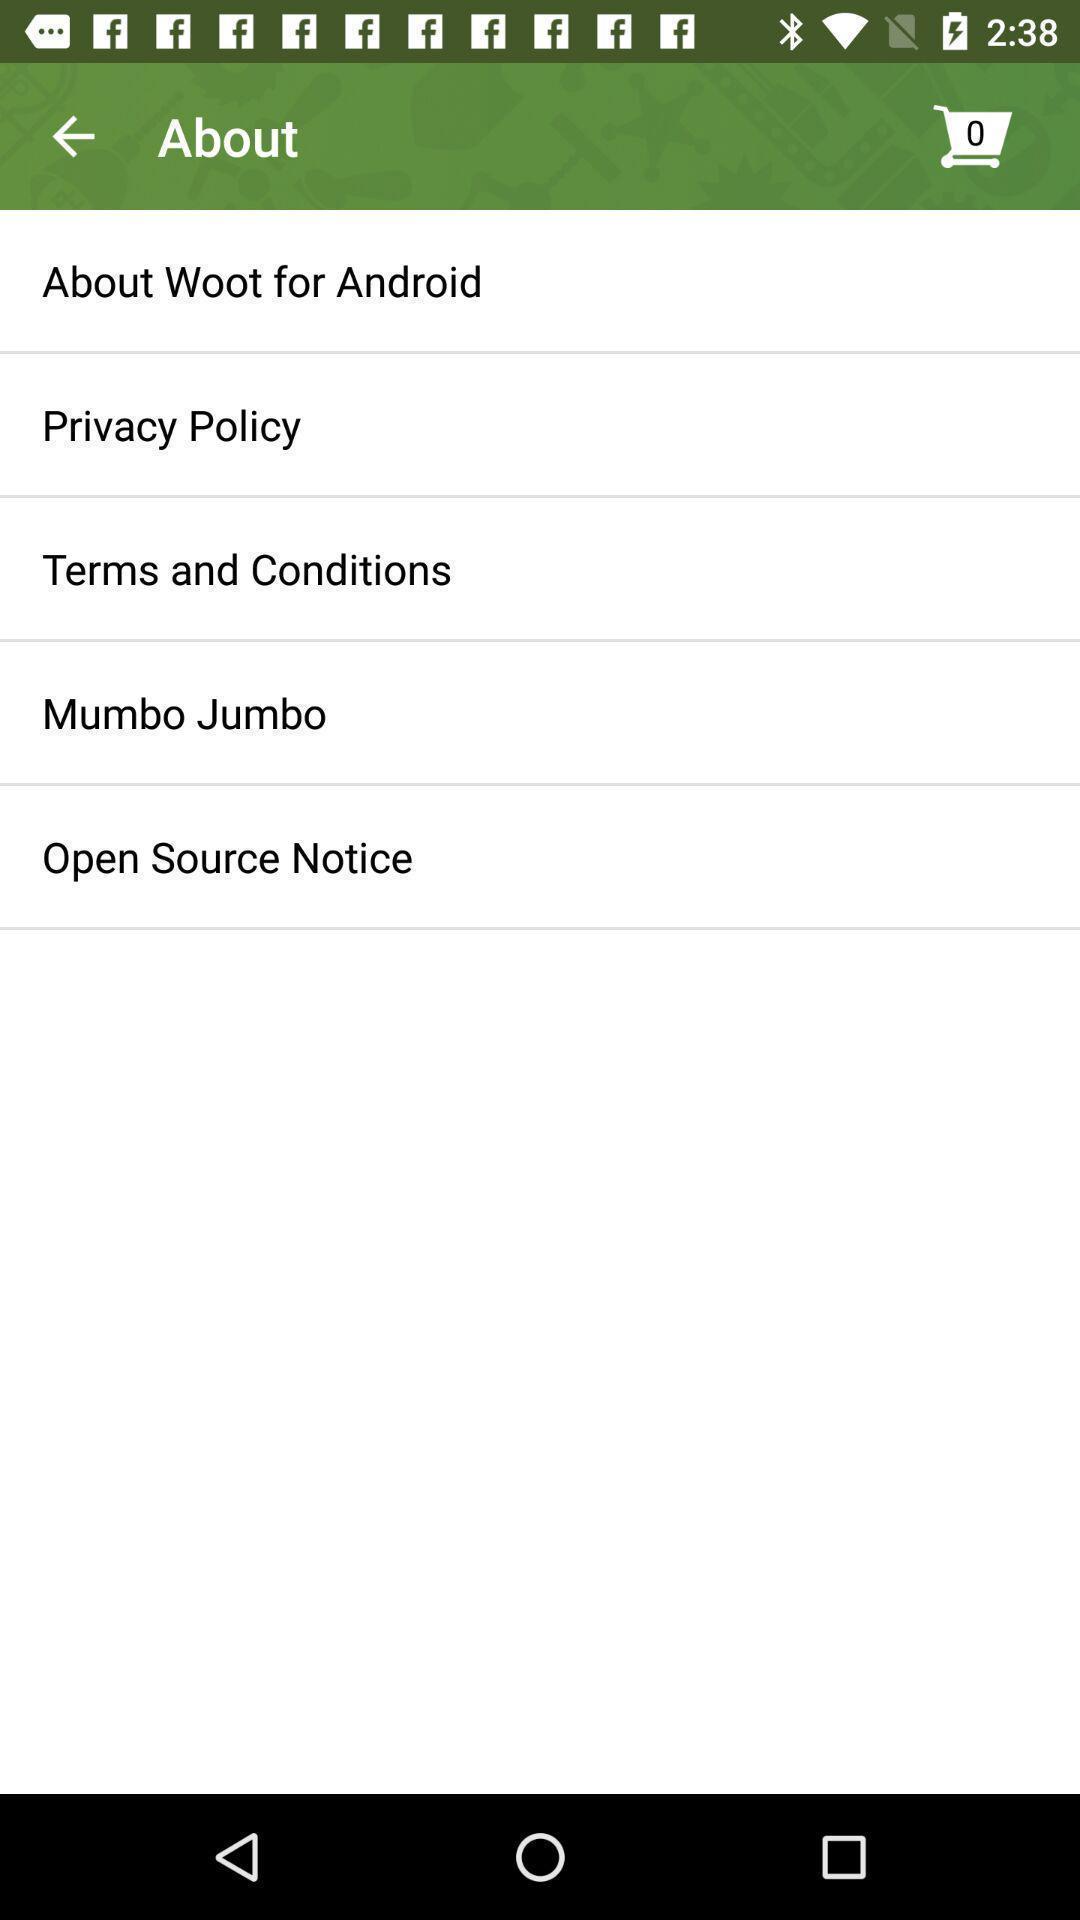Summarize the main components in this picture. Screen shows information about shopping app. 